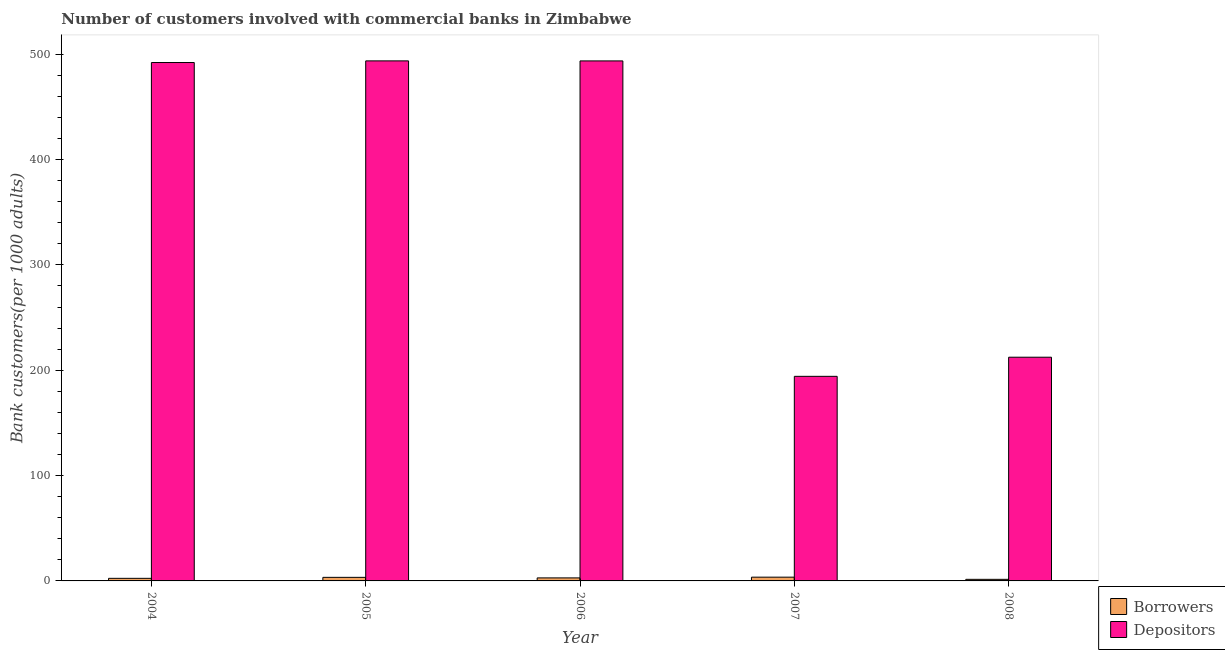Are the number of bars per tick equal to the number of legend labels?
Give a very brief answer. Yes. How many bars are there on the 1st tick from the left?
Keep it short and to the point. 2. How many bars are there on the 3rd tick from the right?
Your answer should be very brief. 2. What is the label of the 2nd group of bars from the left?
Your answer should be very brief. 2005. What is the number of depositors in 2004?
Your answer should be very brief. 492.08. Across all years, what is the maximum number of depositors?
Provide a short and direct response. 493.65. Across all years, what is the minimum number of depositors?
Provide a succinct answer. 194.19. In which year was the number of depositors maximum?
Ensure brevity in your answer.  2005. In which year was the number of depositors minimum?
Provide a succinct answer. 2007. What is the total number of depositors in the graph?
Offer a terse response. 1885.89. What is the difference between the number of borrowers in 2005 and that in 2007?
Offer a very short reply. -0.19. What is the difference between the number of depositors in 2006 and the number of borrowers in 2007?
Your answer should be very brief. 299.42. What is the average number of depositors per year?
Your answer should be compact. 377.18. In the year 2004, what is the difference between the number of borrowers and number of depositors?
Your answer should be very brief. 0. What is the ratio of the number of borrowers in 2005 to that in 2008?
Offer a terse response. 2.24. Is the difference between the number of depositors in 2007 and 2008 greater than the difference between the number of borrowers in 2007 and 2008?
Ensure brevity in your answer.  No. What is the difference between the highest and the second highest number of borrowers?
Your answer should be compact. 0.19. What is the difference between the highest and the lowest number of borrowers?
Your answer should be very brief. 2.06. In how many years, is the number of depositors greater than the average number of depositors taken over all years?
Provide a succinct answer. 3. What does the 2nd bar from the left in 2005 represents?
Your answer should be very brief. Depositors. What does the 1st bar from the right in 2007 represents?
Offer a very short reply. Depositors. Are all the bars in the graph horizontal?
Make the answer very short. No. What is the difference between two consecutive major ticks on the Y-axis?
Offer a terse response. 100. Does the graph contain grids?
Offer a terse response. No. How many legend labels are there?
Give a very brief answer. 2. What is the title of the graph?
Offer a very short reply. Number of customers involved with commercial banks in Zimbabwe. What is the label or title of the X-axis?
Keep it short and to the point. Year. What is the label or title of the Y-axis?
Your response must be concise. Bank customers(per 1000 adults). What is the Bank customers(per 1000 adults) of Borrowers in 2004?
Keep it short and to the point. 2.46. What is the Bank customers(per 1000 adults) of Depositors in 2004?
Your answer should be compact. 492.08. What is the Bank customers(per 1000 adults) of Borrowers in 2005?
Ensure brevity in your answer.  3.38. What is the Bank customers(per 1000 adults) of Depositors in 2005?
Make the answer very short. 493.65. What is the Bank customers(per 1000 adults) in Borrowers in 2006?
Provide a short and direct response. 2.87. What is the Bank customers(per 1000 adults) in Depositors in 2006?
Your response must be concise. 493.61. What is the Bank customers(per 1000 adults) of Borrowers in 2007?
Your answer should be compact. 3.57. What is the Bank customers(per 1000 adults) in Depositors in 2007?
Give a very brief answer. 194.19. What is the Bank customers(per 1000 adults) of Borrowers in 2008?
Your answer should be compact. 1.51. What is the Bank customers(per 1000 adults) of Depositors in 2008?
Your answer should be compact. 212.35. Across all years, what is the maximum Bank customers(per 1000 adults) of Borrowers?
Your answer should be compact. 3.57. Across all years, what is the maximum Bank customers(per 1000 adults) of Depositors?
Offer a very short reply. 493.65. Across all years, what is the minimum Bank customers(per 1000 adults) of Borrowers?
Your answer should be compact. 1.51. Across all years, what is the minimum Bank customers(per 1000 adults) of Depositors?
Provide a short and direct response. 194.19. What is the total Bank customers(per 1000 adults) of Borrowers in the graph?
Your answer should be compact. 13.79. What is the total Bank customers(per 1000 adults) in Depositors in the graph?
Your answer should be very brief. 1885.89. What is the difference between the Bank customers(per 1000 adults) of Borrowers in 2004 and that in 2005?
Offer a very short reply. -0.92. What is the difference between the Bank customers(per 1000 adults) in Depositors in 2004 and that in 2005?
Provide a succinct answer. -1.57. What is the difference between the Bank customers(per 1000 adults) of Borrowers in 2004 and that in 2006?
Provide a short and direct response. -0.41. What is the difference between the Bank customers(per 1000 adults) of Depositors in 2004 and that in 2006?
Your response must be concise. -1.53. What is the difference between the Bank customers(per 1000 adults) of Borrowers in 2004 and that in 2007?
Ensure brevity in your answer.  -1.11. What is the difference between the Bank customers(per 1000 adults) of Depositors in 2004 and that in 2007?
Make the answer very short. 297.89. What is the difference between the Bank customers(per 1000 adults) in Borrowers in 2004 and that in 2008?
Keep it short and to the point. 0.95. What is the difference between the Bank customers(per 1000 adults) of Depositors in 2004 and that in 2008?
Provide a succinct answer. 279.73. What is the difference between the Bank customers(per 1000 adults) of Borrowers in 2005 and that in 2006?
Your answer should be very brief. 0.52. What is the difference between the Bank customers(per 1000 adults) in Depositors in 2005 and that in 2006?
Ensure brevity in your answer.  0.04. What is the difference between the Bank customers(per 1000 adults) in Borrowers in 2005 and that in 2007?
Keep it short and to the point. -0.19. What is the difference between the Bank customers(per 1000 adults) in Depositors in 2005 and that in 2007?
Offer a very short reply. 299.46. What is the difference between the Bank customers(per 1000 adults) of Borrowers in 2005 and that in 2008?
Ensure brevity in your answer.  1.88. What is the difference between the Bank customers(per 1000 adults) of Depositors in 2005 and that in 2008?
Ensure brevity in your answer.  281.3. What is the difference between the Bank customers(per 1000 adults) in Borrowers in 2006 and that in 2007?
Offer a terse response. -0.71. What is the difference between the Bank customers(per 1000 adults) in Depositors in 2006 and that in 2007?
Provide a short and direct response. 299.42. What is the difference between the Bank customers(per 1000 adults) in Borrowers in 2006 and that in 2008?
Provide a succinct answer. 1.36. What is the difference between the Bank customers(per 1000 adults) in Depositors in 2006 and that in 2008?
Make the answer very short. 281.26. What is the difference between the Bank customers(per 1000 adults) of Borrowers in 2007 and that in 2008?
Keep it short and to the point. 2.06. What is the difference between the Bank customers(per 1000 adults) of Depositors in 2007 and that in 2008?
Your response must be concise. -18.16. What is the difference between the Bank customers(per 1000 adults) in Borrowers in 2004 and the Bank customers(per 1000 adults) in Depositors in 2005?
Provide a short and direct response. -491.19. What is the difference between the Bank customers(per 1000 adults) in Borrowers in 2004 and the Bank customers(per 1000 adults) in Depositors in 2006?
Give a very brief answer. -491.15. What is the difference between the Bank customers(per 1000 adults) of Borrowers in 2004 and the Bank customers(per 1000 adults) of Depositors in 2007?
Your answer should be very brief. -191.73. What is the difference between the Bank customers(per 1000 adults) of Borrowers in 2004 and the Bank customers(per 1000 adults) of Depositors in 2008?
Make the answer very short. -209.89. What is the difference between the Bank customers(per 1000 adults) in Borrowers in 2005 and the Bank customers(per 1000 adults) in Depositors in 2006?
Offer a very short reply. -490.23. What is the difference between the Bank customers(per 1000 adults) of Borrowers in 2005 and the Bank customers(per 1000 adults) of Depositors in 2007?
Offer a terse response. -190.81. What is the difference between the Bank customers(per 1000 adults) of Borrowers in 2005 and the Bank customers(per 1000 adults) of Depositors in 2008?
Keep it short and to the point. -208.97. What is the difference between the Bank customers(per 1000 adults) of Borrowers in 2006 and the Bank customers(per 1000 adults) of Depositors in 2007?
Ensure brevity in your answer.  -191.33. What is the difference between the Bank customers(per 1000 adults) of Borrowers in 2006 and the Bank customers(per 1000 adults) of Depositors in 2008?
Provide a succinct answer. -209.48. What is the difference between the Bank customers(per 1000 adults) of Borrowers in 2007 and the Bank customers(per 1000 adults) of Depositors in 2008?
Offer a terse response. -208.78. What is the average Bank customers(per 1000 adults) of Borrowers per year?
Your answer should be very brief. 2.76. What is the average Bank customers(per 1000 adults) of Depositors per year?
Provide a succinct answer. 377.18. In the year 2004, what is the difference between the Bank customers(per 1000 adults) of Borrowers and Bank customers(per 1000 adults) of Depositors?
Offer a very short reply. -489.62. In the year 2005, what is the difference between the Bank customers(per 1000 adults) in Borrowers and Bank customers(per 1000 adults) in Depositors?
Keep it short and to the point. -490.27. In the year 2006, what is the difference between the Bank customers(per 1000 adults) in Borrowers and Bank customers(per 1000 adults) in Depositors?
Your response must be concise. -490.75. In the year 2007, what is the difference between the Bank customers(per 1000 adults) of Borrowers and Bank customers(per 1000 adults) of Depositors?
Provide a succinct answer. -190.62. In the year 2008, what is the difference between the Bank customers(per 1000 adults) in Borrowers and Bank customers(per 1000 adults) in Depositors?
Provide a succinct answer. -210.84. What is the ratio of the Bank customers(per 1000 adults) in Borrowers in 2004 to that in 2005?
Give a very brief answer. 0.73. What is the ratio of the Bank customers(per 1000 adults) in Depositors in 2004 to that in 2005?
Your response must be concise. 1. What is the ratio of the Bank customers(per 1000 adults) in Borrowers in 2004 to that in 2006?
Keep it short and to the point. 0.86. What is the ratio of the Bank customers(per 1000 adults) of Depositors in 2004 to that in 2006?
Provide a succinct answer. 1. What is the ratio of the Bank customers(per 1000 adults) in Borrowers in 2004 to that in 2007?
Provide a succinct answer. 0.69. What is the ratio of the Bank customers(per 1000 adults) of Depositors in 2004 to that in 2007?
Ensure brevity in your answer.  2.53. What is the ratio of the Bank customers(per 1000 adults) of Borrowers in 2004 to that in 2008?
Offer a terse response. 1.63. What is the ratio of the Bank customers(per 1000 adults) of Depositors in 2004 to that in 2008?
Ensure brevity in your answer.  2.32. What is the ratio of the Bank customers(per 1000 adults) in Borrowers in 2005 to that in 2006?
Provide a short and direct response. 1.18. What is the ratio of the Bank customers(per 1000 adults) in Depositors in 2005 to that in 2006?
Provide a succinct answer. 1. What is the ratio of the Bank customers(per 1000 adults) of Borrowers in 2005 to that in 2007?
Your response must be concise. 0.95. What is the ratio of the Bank customers(per 1000 adults) in Depositors in 2005 to that in 2007?
Your answer should be compact. 2.54. What is the ratio of the Bank customers(per 1000 adults) in Borrowers in 2005 to that in 2008?
Keep it short and to the point. 2.24. What is the ratio of the Bank customers(per 1000 adults) in Depositors in 2005 to that in 2008?
Ensure brevity in your answer.  2.32. What is the ratio of the Bank customers(per 1000 adults) of Borrowers in 2006 to that in 2007?
Your answer should be compact. 0.8. What is the ratio of the Bank customers(per 1000 adults) of Depositors in 2006 to that in 2007?
Keep it short and to the point. 2.54. What is the ratio of the Bank customers(per 1000 adults) in Borrowers in 2006 to that in 2008?
Provide a succinct answer. 1.9. What is the ratio of the Bank customers(per 1000 adults) in Depositors in 2006 to that in 2008?
Your answer should be very brief. 2.32. What is the ratio of the Bank customers(per 1000 adults) of Borrowers in 2007 to that in 2008?
Ensure brevity in your answer.  2.37. What is the ratio of the Bank customers(per 1000 adults) of Depositors in 2007 to that in 2008?
Ensure brevity in your answer.  0.91. What is the difference between the highest and the second highest Bank customers(per 1000 adults) in Borrowers?
Offer a terse response. 0.19. What is the difference between the highest and the second highest Bank customers(per 1000 adults) of Depositors?
Offer a terse response. 0.04. What is the difference between the highest and the lowest Bank customers(per 1000 adults) of Borrowers?
Your response must be concise. 2.06. What is the difference between the highest and the lowest Bank customers(per 1000 adults) of Depositors?
Your answer should be compact. 299.46. 